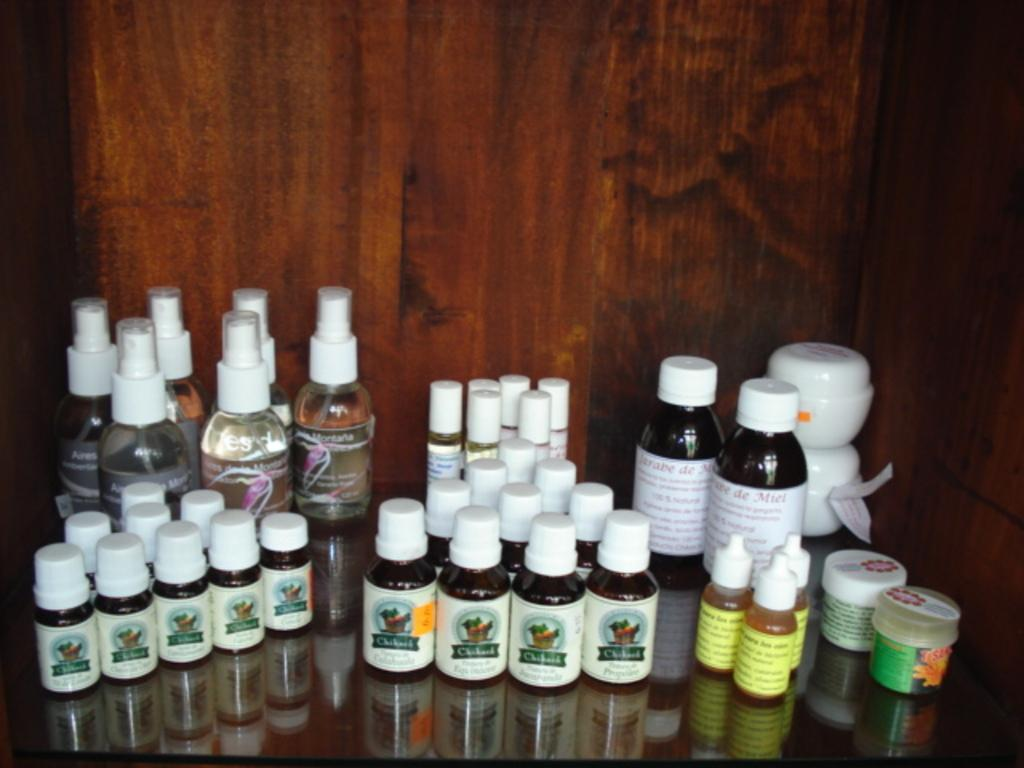What objects are present in the image? There are bottles in the image. Can you describe the bottles in more detail? The bottles are of different types. What material is the table made of? The table is made of glass. What type of joke is written on the page in the image? There is no page or joke present in the image; it only features bottles on a glass table. 